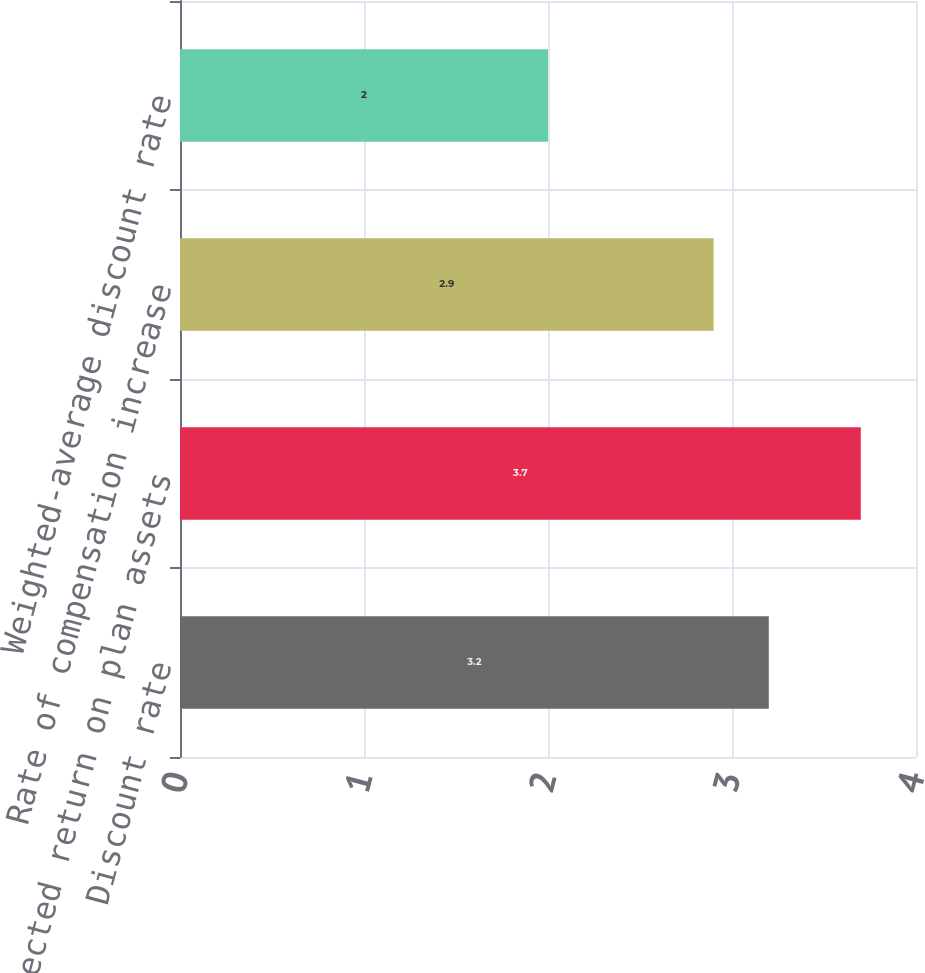Convert chart. <chart><loc_0><loc_0><loc_500><loc_500><bar_chart><fcel>Discount rate<fcel>Expected return on plan assets<fcel>Rate of compensation increase<fcel>Weighted-average discount rate<nl><fcel>3.2<fcel>3.7<fcel>2.9<fcel>2<nl></chart> 